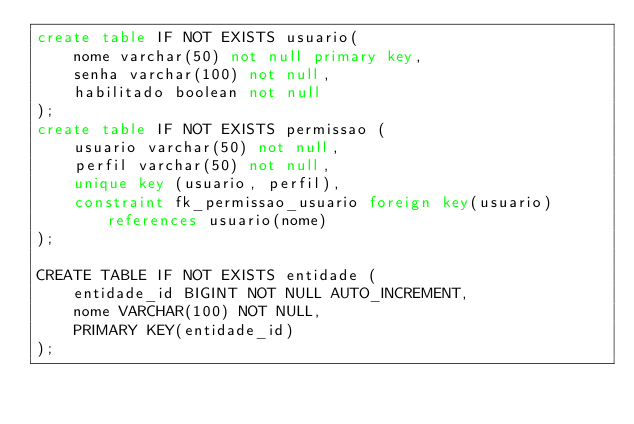<code> <loc_0><loc_0><loc_500><loc_500><_SQL_>create table IF NOT EXISTS usuario(
	nome varchar(50) not null primary key,
	senha varchar(100) not null,
	habilitado boolean not null
);
create table IF NOT EXISTS permissao (
	usuario varchar(50) not null,
	perfil varchar(50) not null,
	unique key (usuario, perfil),
	constraint fk_permissao_usuario foreign key(usuario) references usuario(nome)
);

CREATE TABLE IF NOT EXISTS entidade (
    entidade_id BIGINT NOT NULL AUTO_INCREMENT, 
    nome VARCHAR(100) NOT NULL, 
    PRIMARY KEY(entidade_id)
);
</code> 